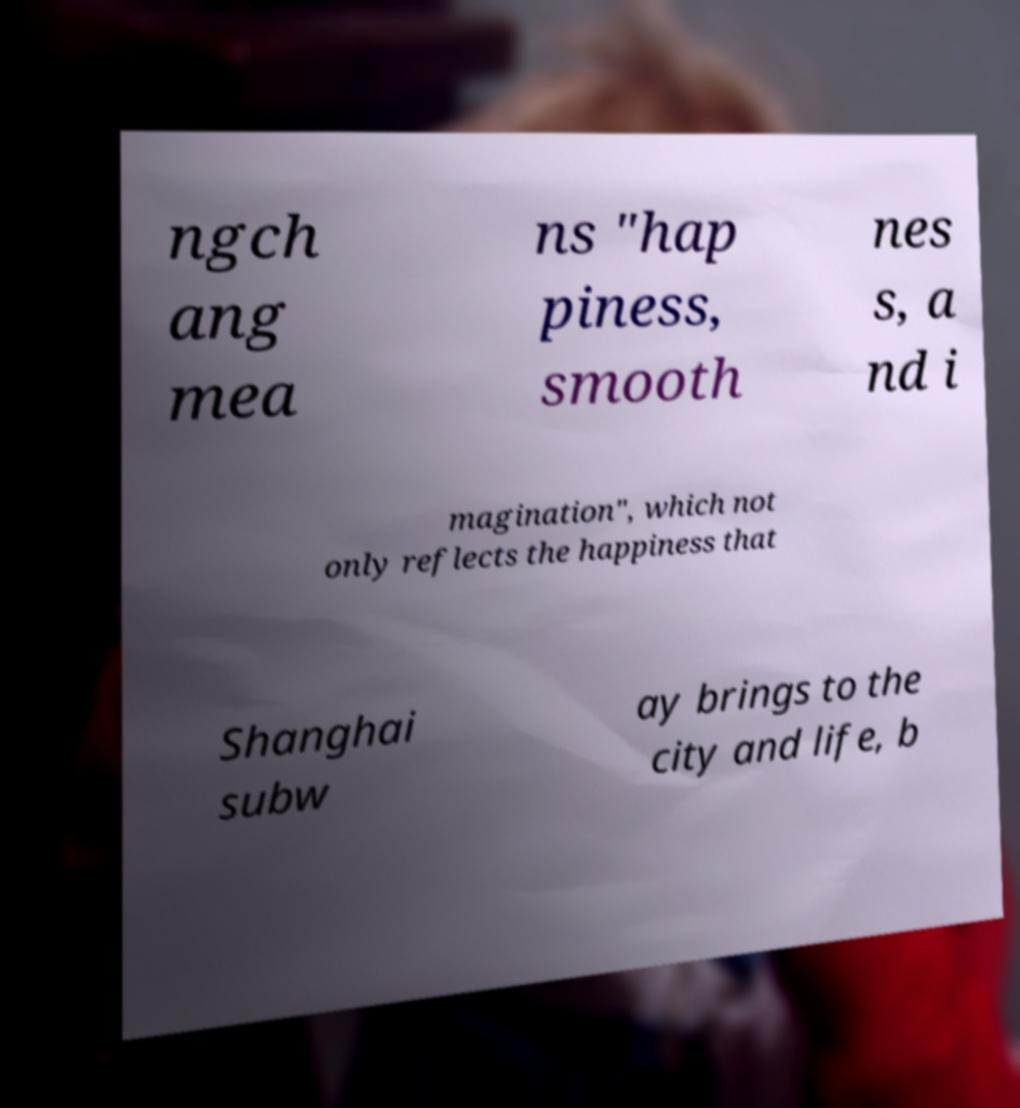Can you accurately transcribe the text from the provided image for me? ngch ang mea ns "hap piness, smooth nes s, a nd i magination", which not only reflects the happiness that Shanghai subw ay brings to the city and life, b 